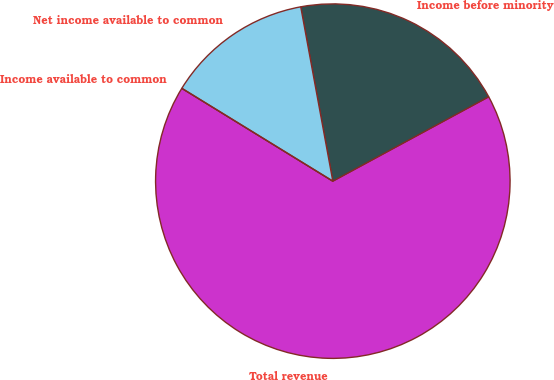<chart> <loc_0><loc_0><loc_500><loc_500><pie_chart><fcel>Total revenue<fcel>Income before minority<fcel>Net income available to common<fcel>Income available to common<nl><fcel>66.67%<fcel>20.0%<fcel>13.33%<fcel>0.0%<nl></chart> 